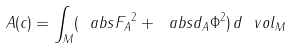Convert formula to latex. <formula><loc_0><loc_0><loc_500><loc_500>\ A ( c ) = \int _ { M } ( \ a b s { F _ { A } } ^ { 2 } + \ a b s { d _ { A } \Phi } ^ { 2 } ) \, d \ v o l _ { M }</formula> 